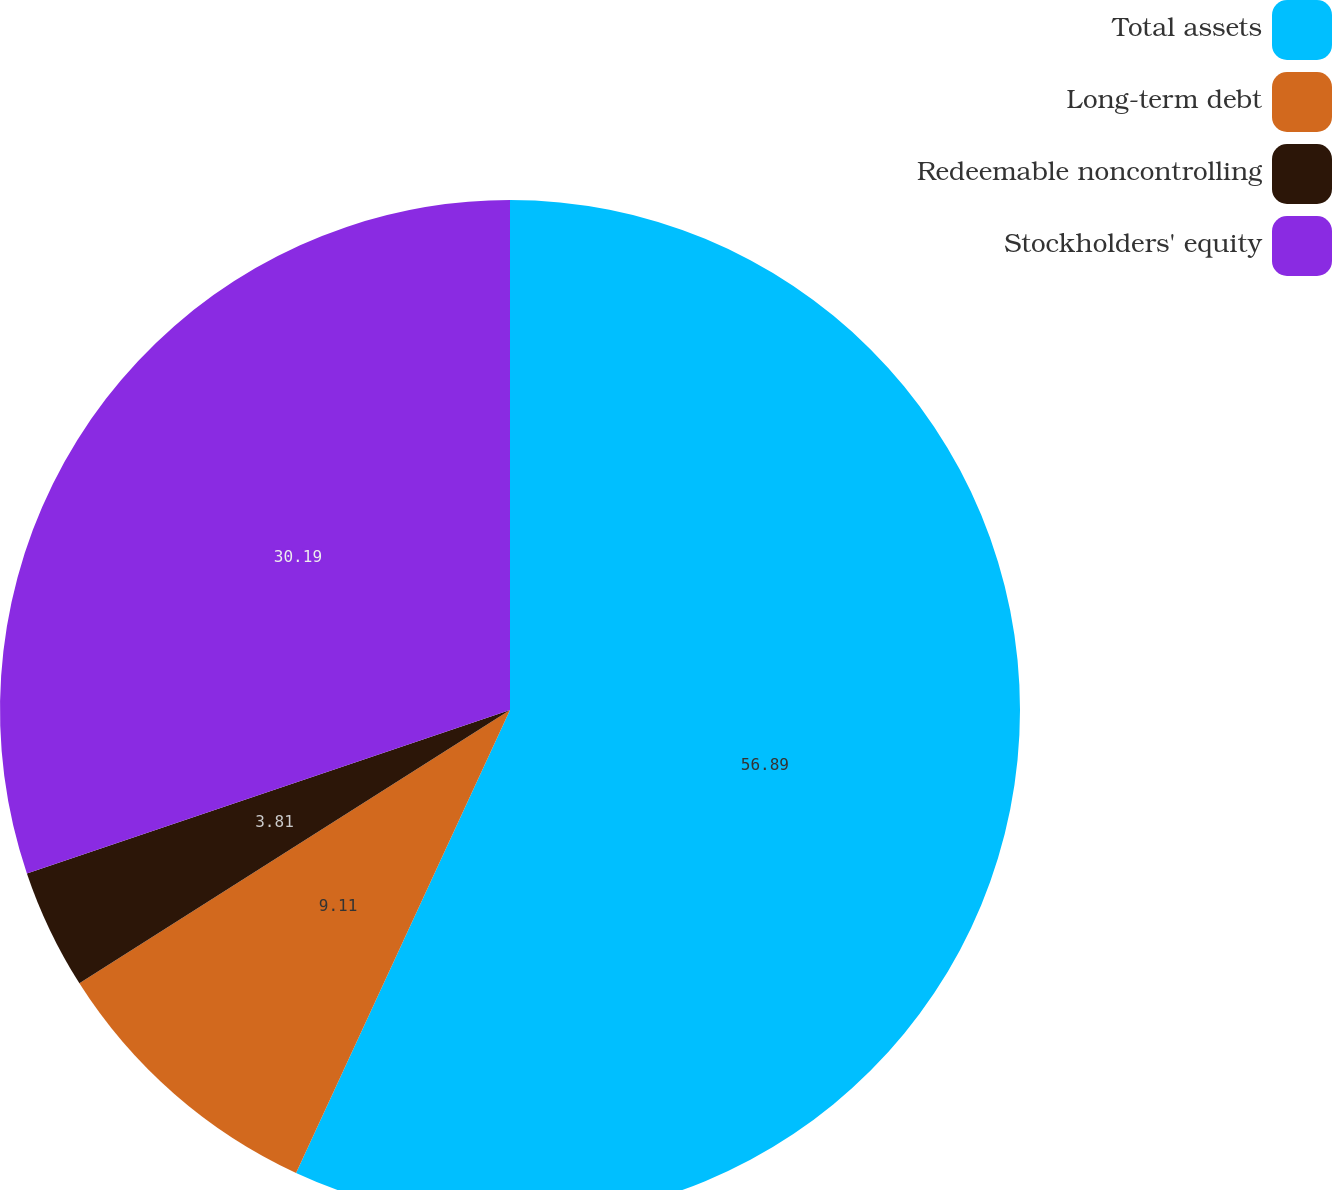<chart> <loc_0><loc_0><loc_500><loc_500><pie_chart><fcel>Total assets<fcel>Long-term debt<fcel>Redeemable noncontrolling<fcel>Stockholders' equity<nl><fcel>56.89%<fcel>9.11%<fcel>3.81%<fcel>30.19%<nl></chart> 